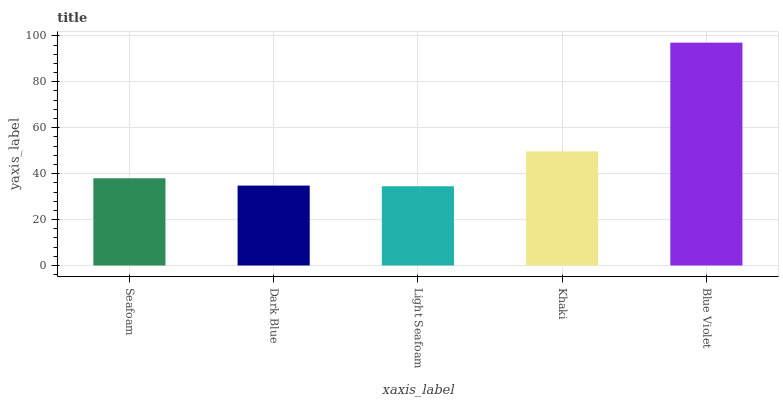Is Light Seafoam the minimum?
Answer yes or no. Yes. Is Blue Violet the maximum?
Answer yes or no. Yes. Is Dark Blue the minimum?
Answer yes or no. No. Is Dark Blue the maximum?
Answer yes or no. No. Is Seafoam greater than Dark Blue?
Answer yes or no. Yes. Is Dark Blue less than Seafoam?
Answer yes or no. Yes. Is Dark Blue greater than Seafoam?
Answer yes or no. No. Is Seafoam less than Dark Blue?
Answer yes or no. No. Is Seafoam the high median?
Answer yes or no. Yes. Is Seafoam the low median?
Answer yes or no. Yes. Is Blue Violet the high median?
Answer yes or no. No. Is Dark Blue the low median?
Answer yes or no. No. 